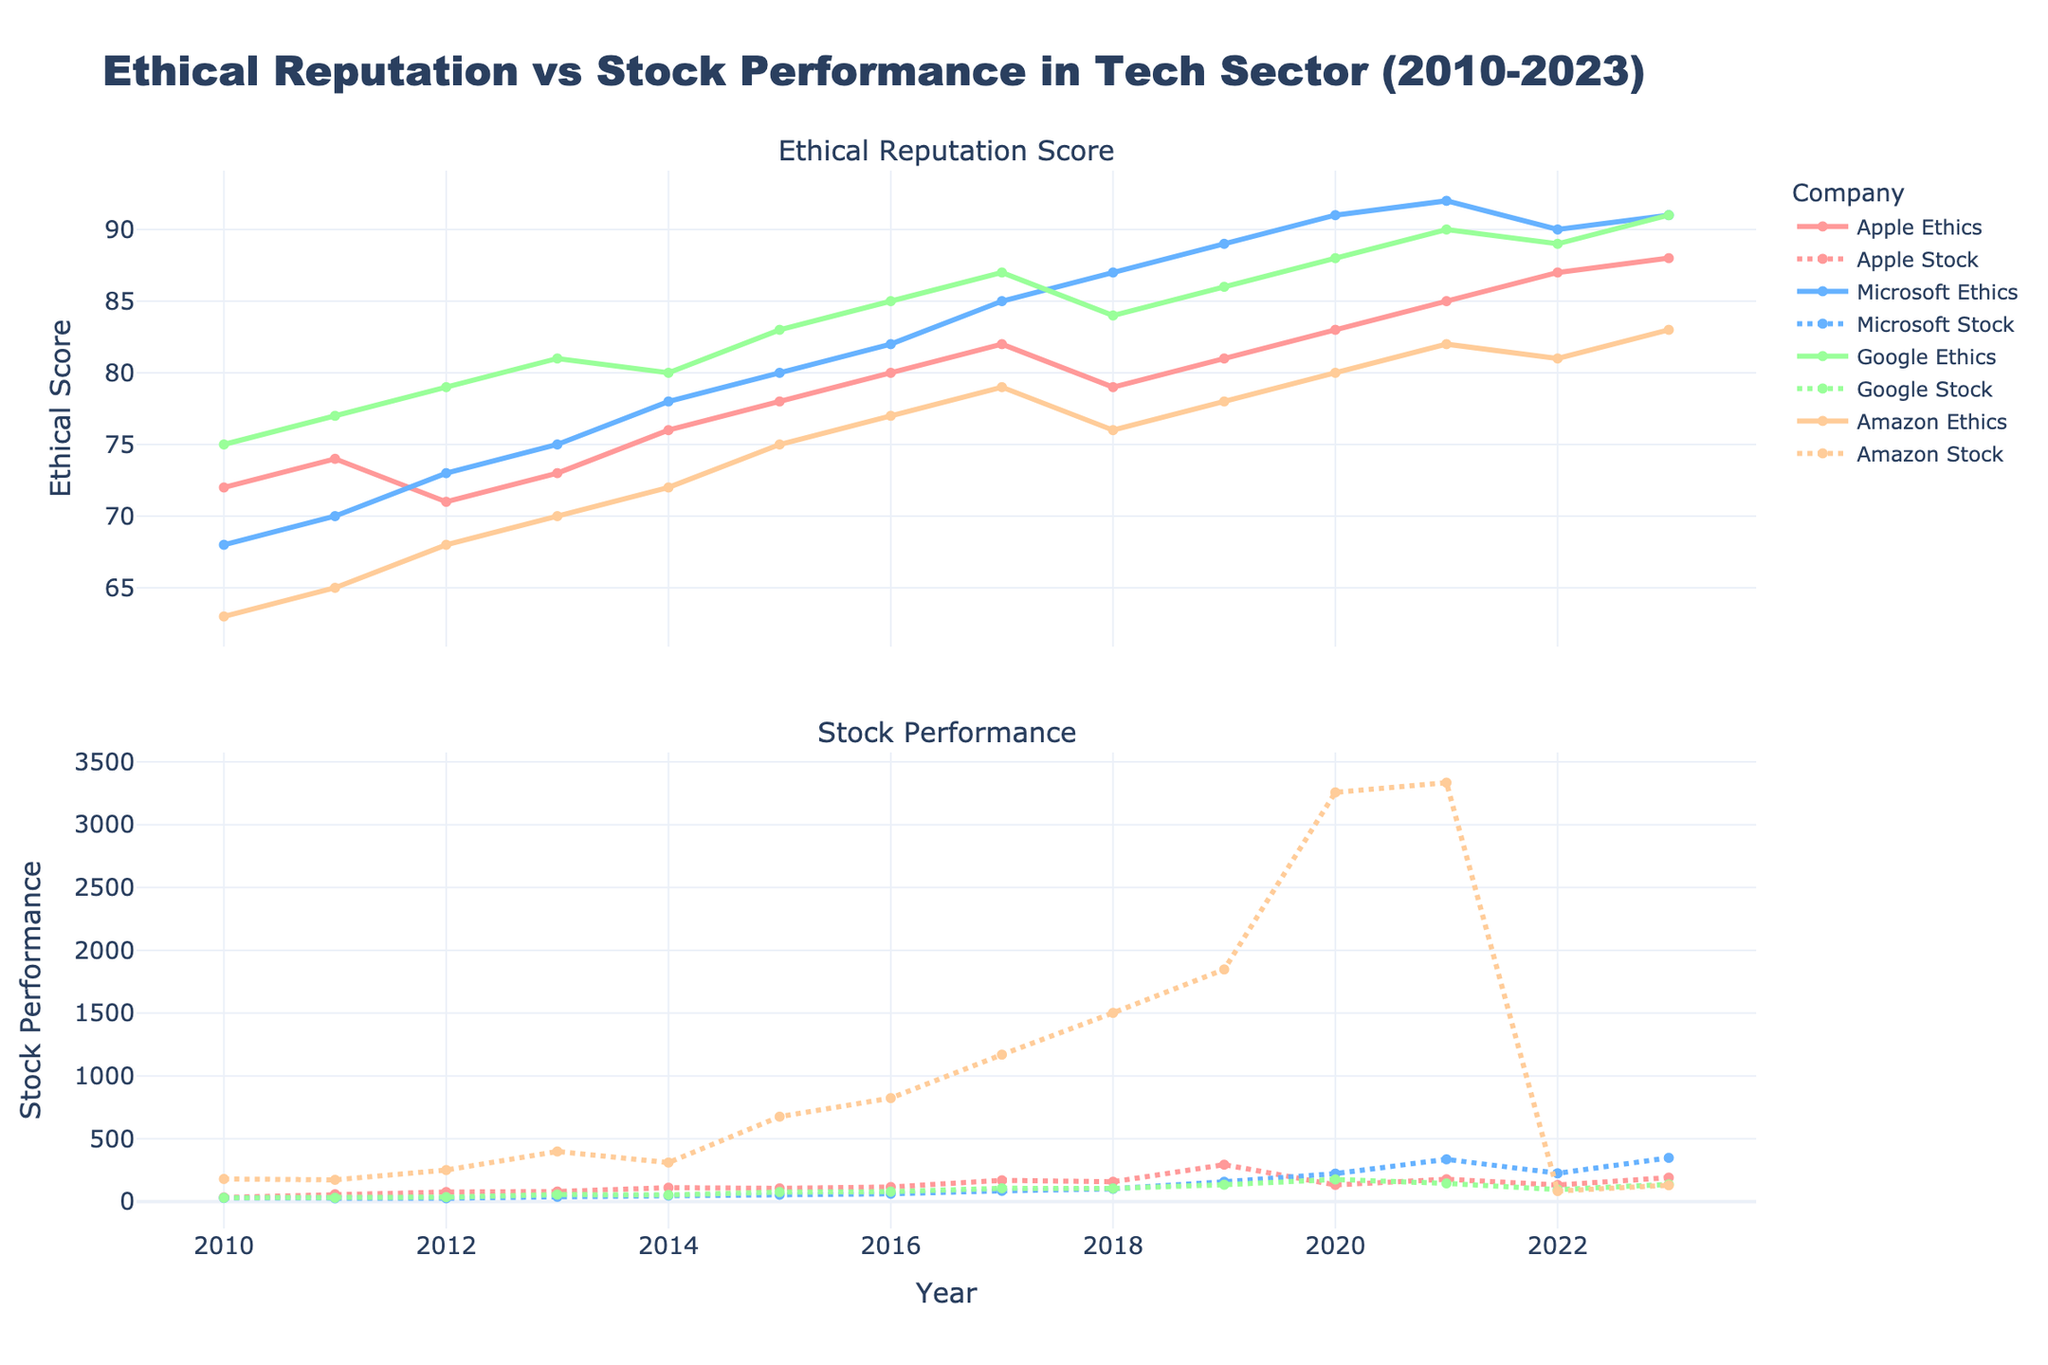What's the general trend of Amazon's ethical reputation score from 2010 to 2023? The ethical reputation score for Amazon starts at 63 in 2010 and gradually increases each year, reaching 83 in 2023. This indicates a positive trend.
Answer: Positive trend How does the stock performance of Apple in 2023 compare to its stock performance in 2010? In 2010, Apple's stock performance was 33.1, and it increased to 190.7 in 2023. To compare, subtract 33.1 from 190.7, which equals 157.6, showing a significant increase.
Answer: Increased by 157.6 Which company had the highest ethical reputation score in 2023? By looking at the 2023 values, Google had the highest ethical reputation score at 91.
Answer: Google Which company had the greatest difference between its highest and lowest ethical reputation scores during the period 2010 to 2023? Amazon’s ethical reputation score increased from 63 in 2010 to 83 in 2023, a difference of 20. No other company shows such a wide range.
Answer: Amazon In which year did Microsoft see the most significant increase in its stock performance from the previous year? Comparing Microsoft's stock performance each year, the most significant increase was between 2022 (224.9) and 2023 (348.1), an increase of 123.2.
Answer: 2023 How does the trend of Google's ethical reputation score relate to its stock performance over the years? Google's ethical reputation score generally increases from 75 in 2010 to 91 in 2023. Its stock performance also shows a consistent increase from 30.2 in 2010 to a peak of 176.3 in 2020, followed by fluctuations. Both show a generally positive trend with Google’s stock performing strongly when its ethical scores are high.
Answer: Positive correlation Between 2017 and 2019, which company had the most consistent increase in both ethical reputation score and stock performance? From 2017 to 2019, Microsoft had consistent increases in both categories, Ethical score from 85 to 89 and Stock performance from 85.5 to 157.7 over these years without any decline.
Answer: Microsoft What was the average ethical reputation score of Apple from 2010 to 2023? Add Apple's ethical scores for each year: 72 + 74 + 71 + 73 + 76 + 78 + 80 + 82 + 79 + 81 + 83 + 85 + 87 + 88 = 1129. Divide by 14 (years) to get the average: 1129 / 14 = 80.64.
Answer: 80.64 Which company had the lowest stock performance in 2023? In 2023, Amazon had the lowest stock performance with a value of 129.8.
Answer: Amazon 